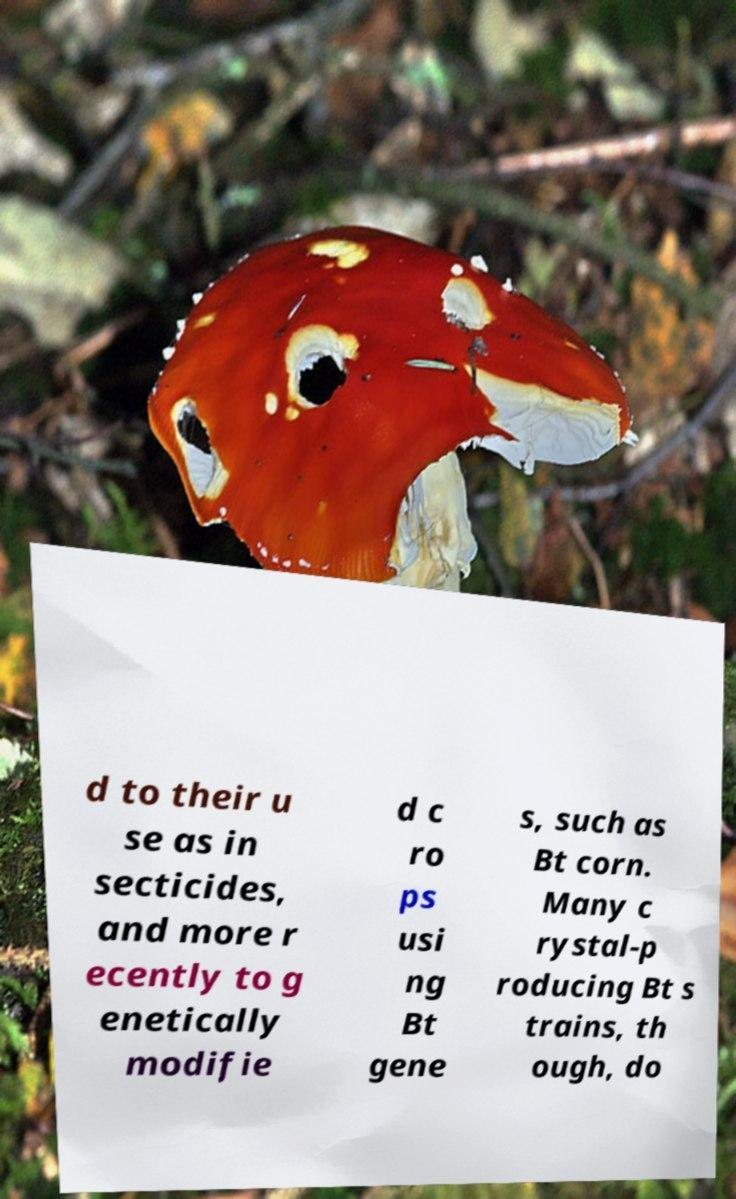Could you assist in decoding the text presented in this image and type it out clearly? d to their u se as in secticides, and more r ecently to g enetically modifie d c ro ps usi ng Bt gene s, such as Bt corn. Many c rystal-p roducing Bt s trains, th ough, do 